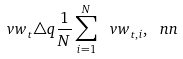<formula> <loc_0><loc_0><loc_500><loc_500>\ v w _ { t } \triangle q \frac { 1 } { N } \sum _ { i = 1 } ^ { N } \ v w _ { t , i } , \ n n</formula> 